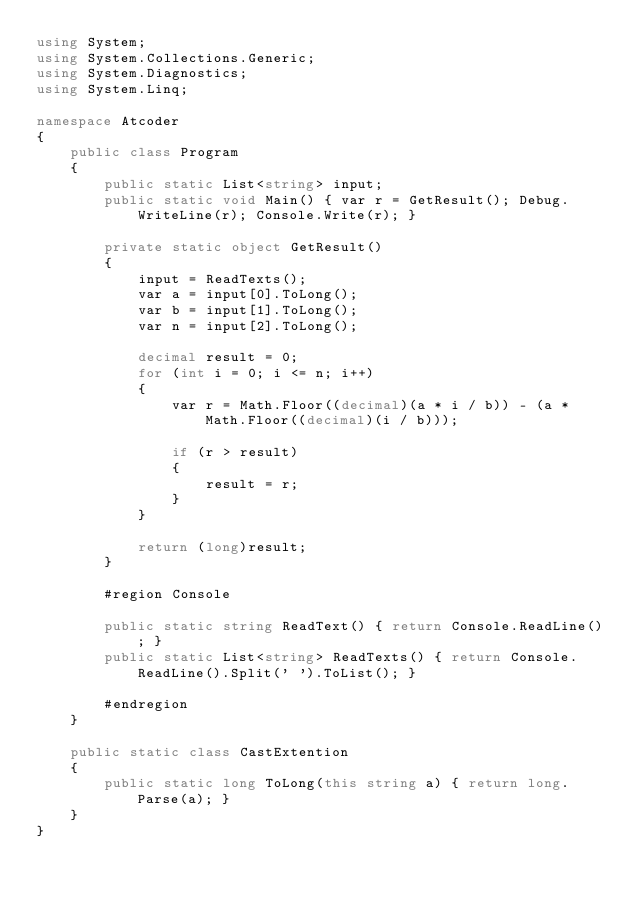<code> <loc_0><loc_0><loc_500><loc_500><_C#_>using System;
using System.Collections.Generic;
using System.Diagnostics;
using System.Linq;

namespace Atcoder
{
    public class Program
    {
        public static List<string> input;
        public static void Main() { var r = GetResult(); Debug.WriteLine(r); Console.Write(r); }

        private static object GetResult()
        {
            input = ReadTexts();
            var a = input[0].ToLong();
            var b = input[1].ToLong();
            var n = input[2].ToLong();

            decimal result = 0;
            for (int i = 0; i <= n; i++)
            {
                var r = Math.Floor((decimal)(a * i / b)) - (a * Math.Floor((decimal)(i / b)));

                if (r > result)
                {
                    result = r;
                }
            }

            return (long)result;
        }

        #region Console

        public static string ReadText() { return Console.ReadLine(); }
        public static List<string> ReadTexts() { return Console.ReadLine().Split(' ').ToList(); }

        #endregion
    }

    public static class CastExtention
    {
        public static long ToLong(this string a) { return long.Parse(a); }
    }
}</code> 